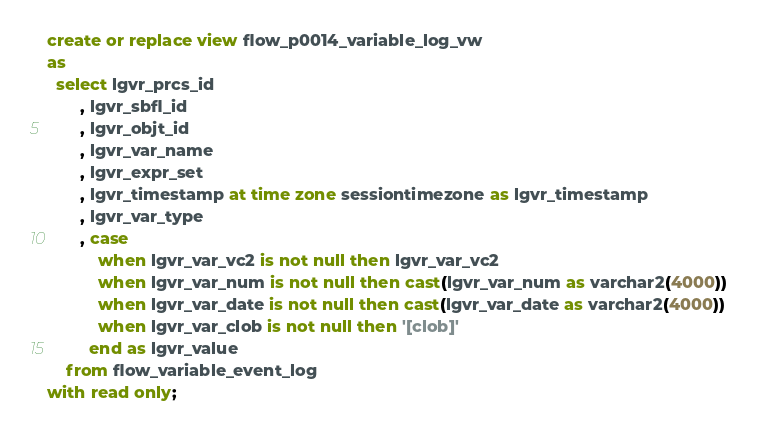Convert code to text. <code><loc_0><loc_0><loc_500><loc_500><_SQL_>create or replace view flow_p0014_variable_log_vw
as
  select lgvr_prcs_id
       , lgvr_sbfl_id
       , lgvr_objt_id
       , lgvr_var_name
       , lgvr_expr_set
       , lgvr_timestamp at time zone sessiontimezone as lgvr_timestamp
       , lgvr_var_type
       , case
           when lgvr_var_vc2 is not null then lgvr_var_vc2
           when lgvr_var_num is not null then cast(lgvr_var_num as varchar2(4000))
           when lgvr_var_date is not null then cast(lgvr_var_date as varchar2(4000))
           when lgvr_var_clob is not null then '[clob]'
         end as lgvr_value
    from flow_variable_event_log
with read only;
</code> 